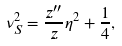<formula> <loc_0><loc_0><loc_500><loc_500>\nu _ { S } ^ { 2 } = \frac { z ^ { \prime \prime } } { z } \eta ^ { 2 } + \frac { 1 } { 4 } ,</formula> 